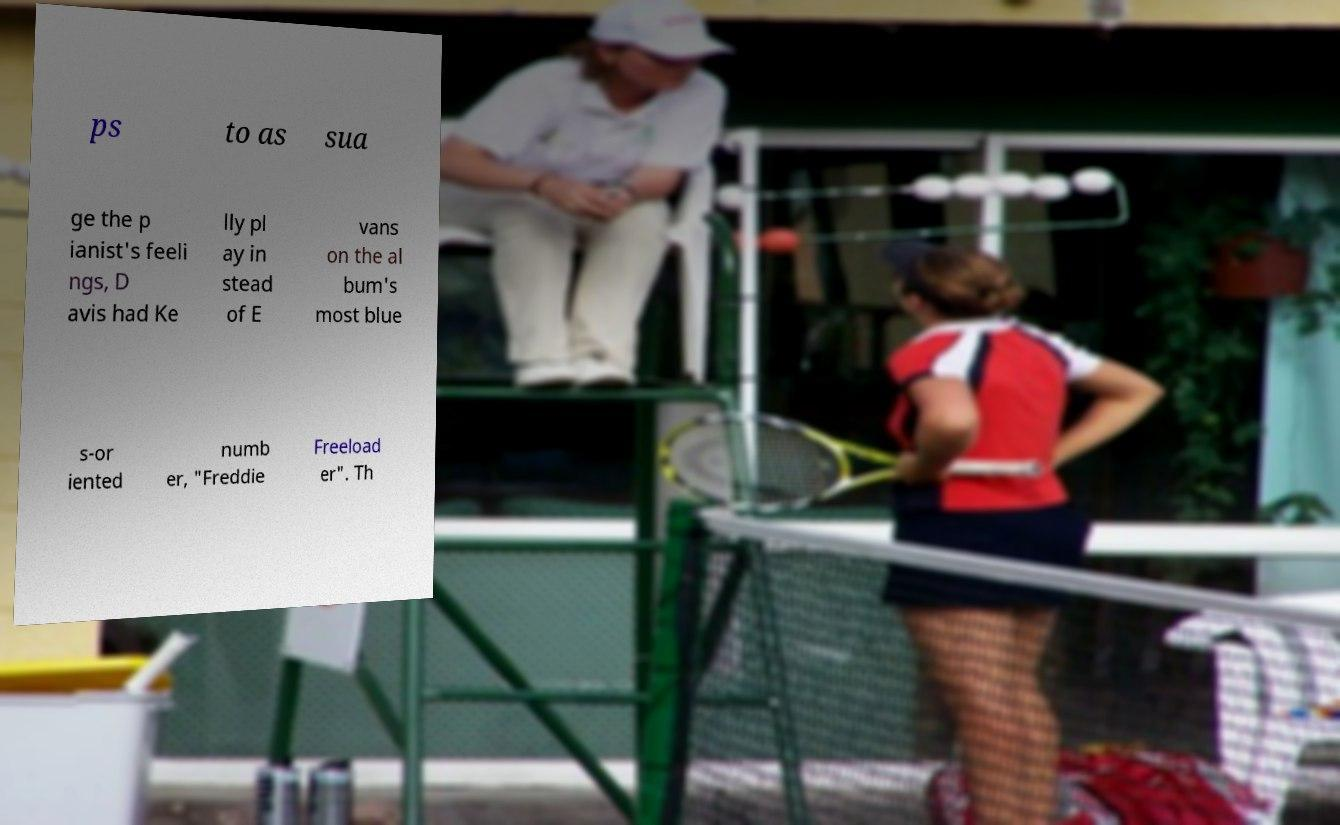Could you extract and type out the text from this image? ps to as sua ge the p ianist's feeli ngs, D avis had Ke lly pl ay in stead of E vans on the al bum's most blue s-or iented numb er, "Freddie Freeload er". Th 